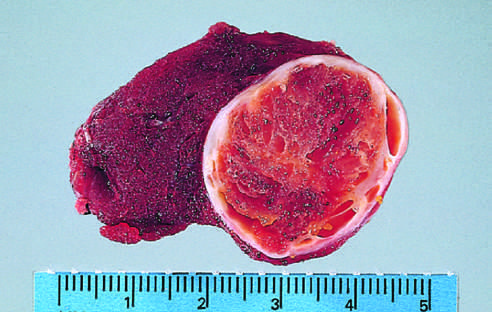what is the tumor composed of?
Answer the question using a single word or phrase. Cells with abundant eosinophilic cytoplasm and small regular nuclei on this high-power view 